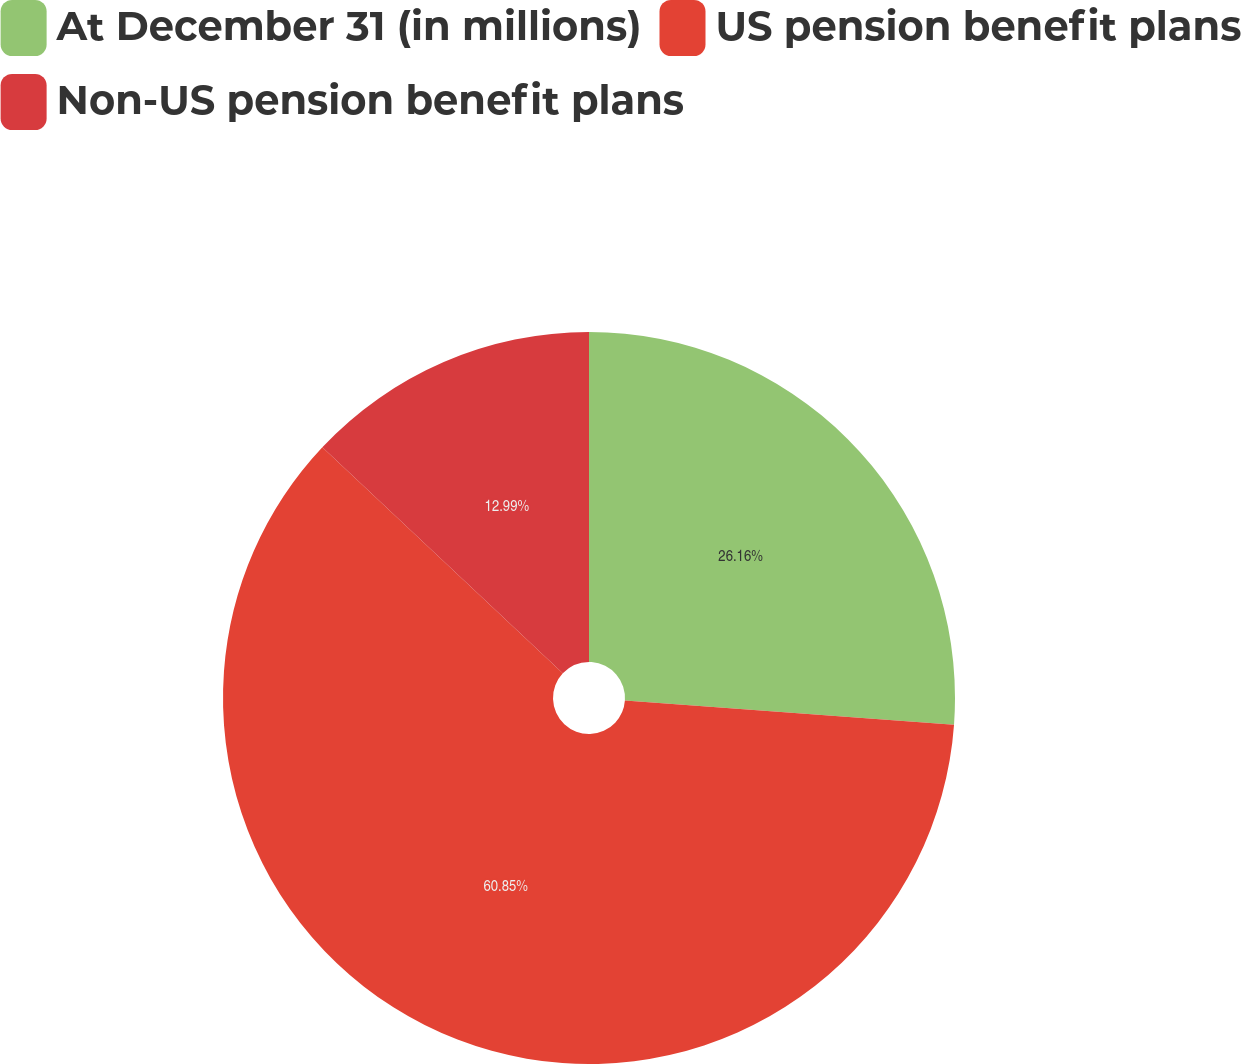<chart> <loc_0><loc_0><loc_500><loc_500><pie_chart><fcel>At December 31 (in millions)<fcel>US pension benefit plans<fcel>Non-US pension benefit plans<nl><fcel>26.16%<fcel>60.85%<fcel>12.99%<nl></chart> 